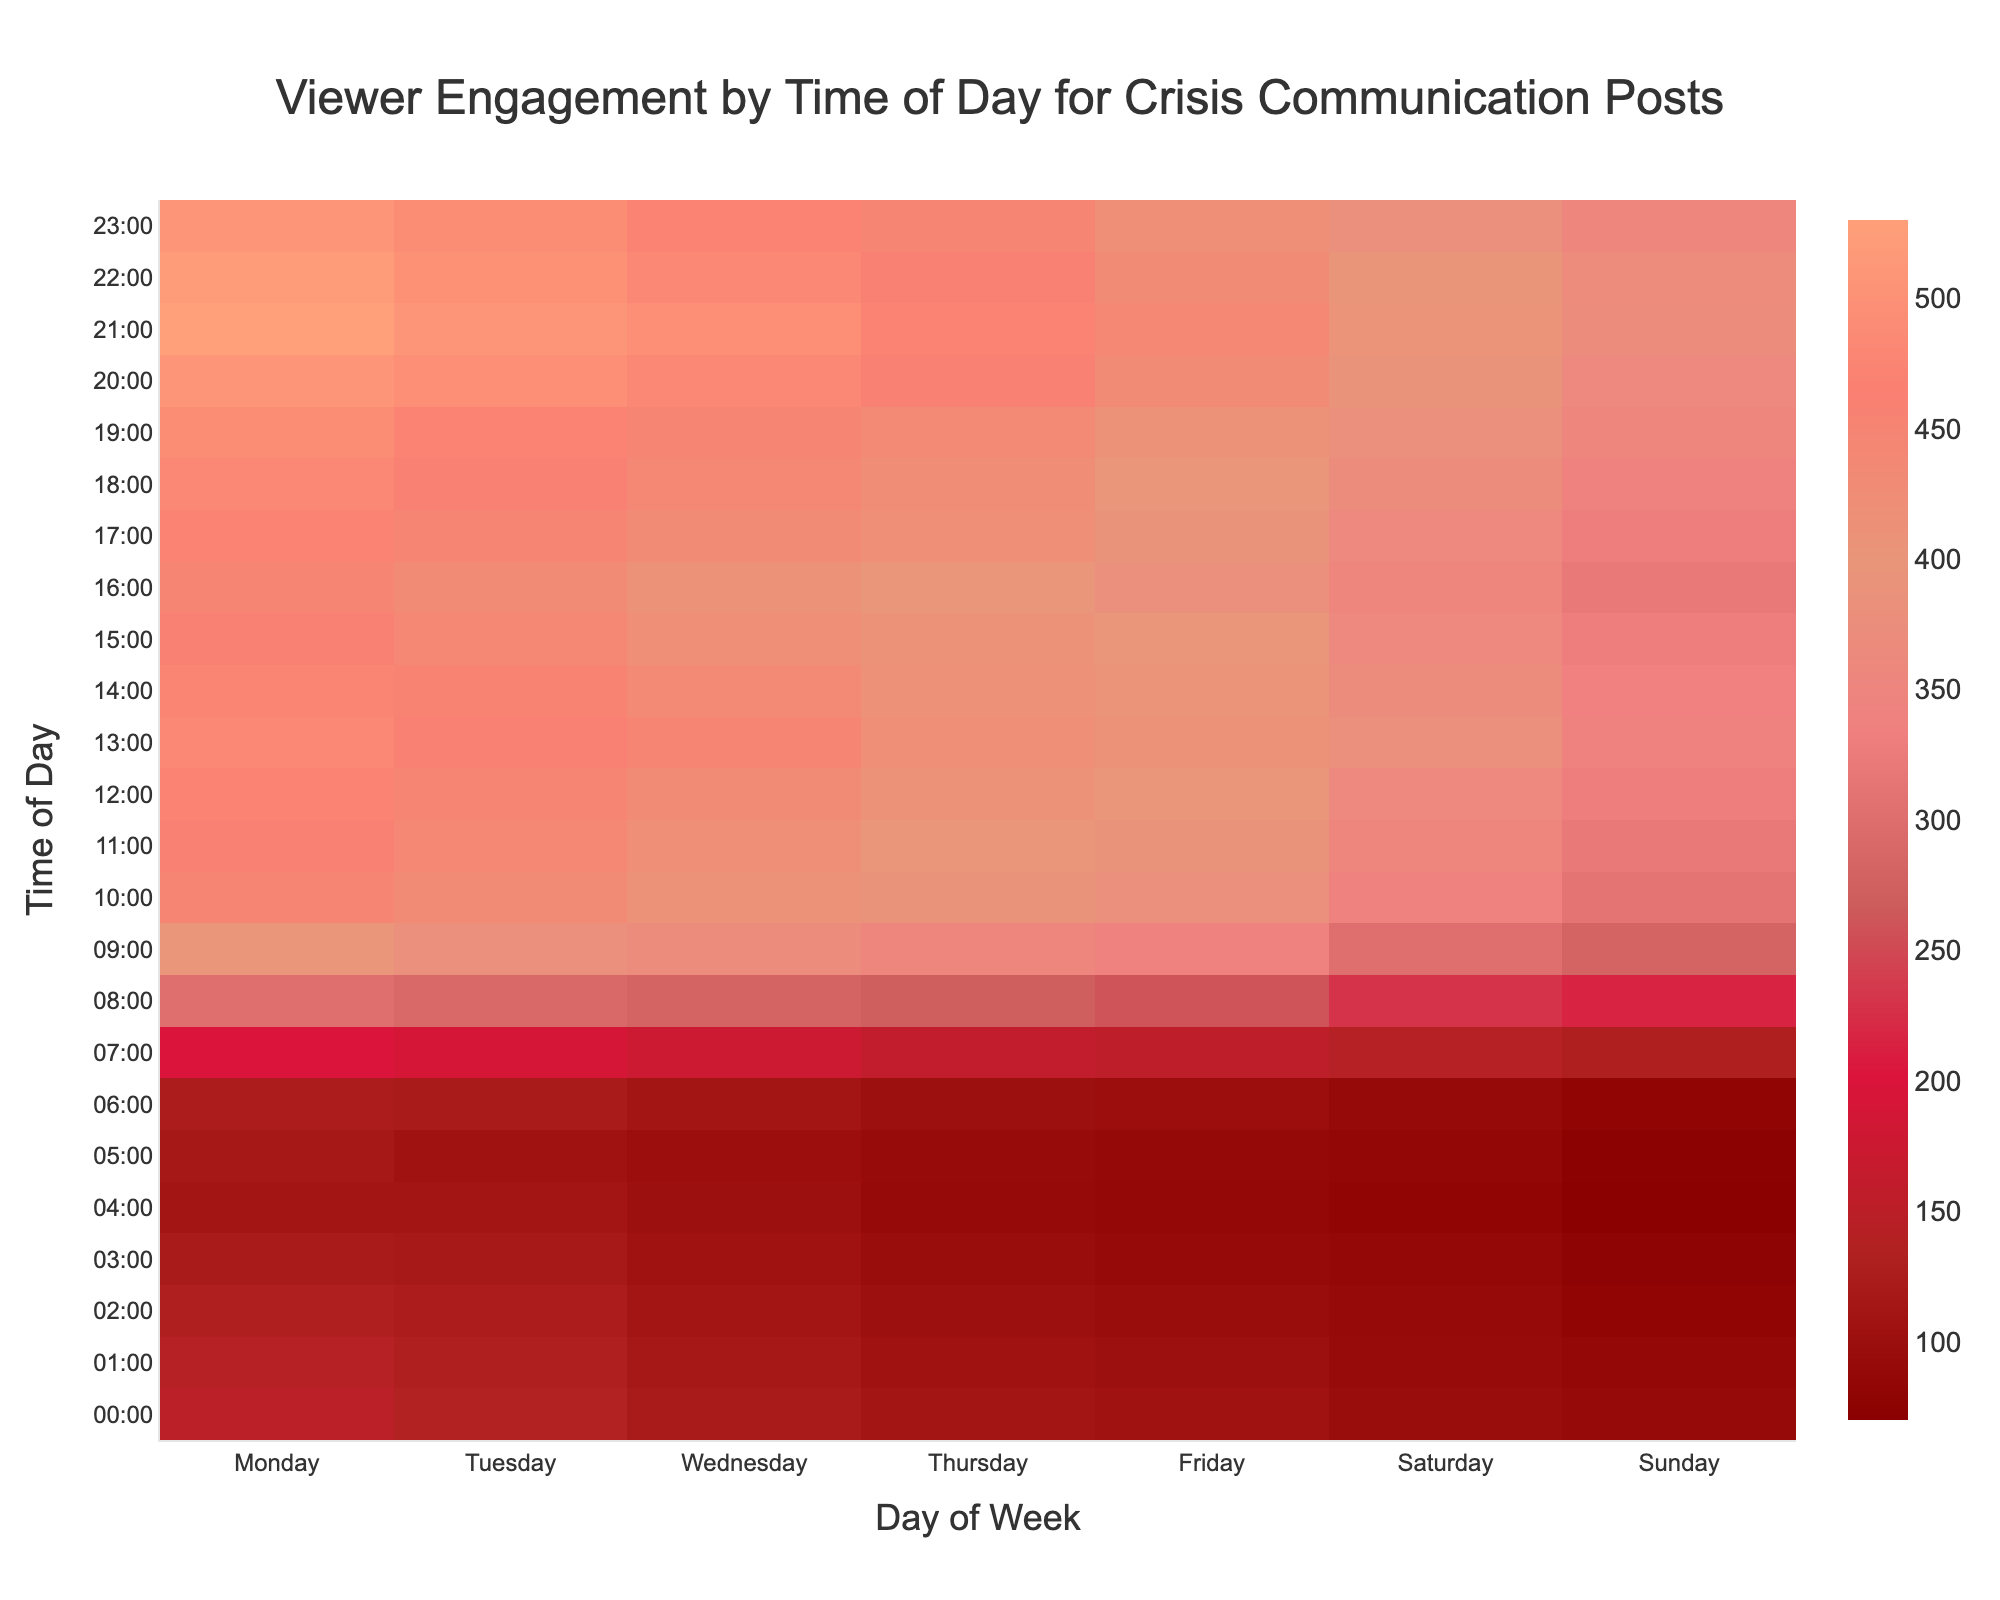What's the title of the heatmap? The title is usually displayed at the top of the figure and conveys the main information about the visualization. Here, the title is "Viewer Engagement by Time of Day for Crisis Communication Posts".
Answer: Viewer Engagement by Time of Day for Crisis Communication Posts Which day has the highest engagement at 8:00 AM? To find this, look at the row corresponding to 8:00 AM. The highest engagement value in that row is 300, which is under Monday.
Answer: Monday At what time do we see a sudden increase in viewer engagement on weekdays? Reviewing the heatmap, there's a noticeable jump between 6:00 AM and 7:00 AM on weekdays. Engagement values rise significantly from 125-155 to 200-155 in this time frame.
Answer: 7:00 AM What's the average engagement on Sunday across all times? The engagement values for Sunday are: 90, 85, 80, 75, 70, 72, 80, 130, 215, 280, 310, 320, 330, 340, 335, 330, 320, 330, 340, 350, 360, 370, 365, and 350. Their sum is 7492, and there are 24 values. The average is 7492 divided by 24.
Answer: 312.17 How does viewer engagement at 9:00 AM on Tuesday compare to Sunday? Check the engagement values at 9:00 AM for both days. Tuesday has 380 and Sunday has 280. Comparing these, Tuesday's engagement is greater than Sunday's by 100.
Answer: 100 more on Tuesday Which two days have the most similar engagements at 10:00 PM and what are the values? Compare the values at 22:00 for all days: Monday (520), Tuesday (500), Wednesday (480), Thursday (460), Friday (430), Saturday (395), and Sunday (365). The closest values are Thursday (460) and Friday (430) with a difference of 30.
Answer: Thursday and Friday: 460, 430 What is the engagement trend throughout the day on Saturday? Looking at the Saturday column, engagement starts lower in the early hours, increases gradually, peaks around midday (noon to afternoon), and then starts to decline towards late night.
Answer: Peaks around midday then declines Which time slot has the highest viewer engagement overall, and what is the value? By reviewing the entire heatmap, the maximum value highlighted is 530, which occurs at 21:00 on Monday.
Answer: 21:00, 530 Compare the engagement at 13:00 on Friday with Wednesday. The values for 13:00 on Friday and Wednesday are 410 and 450, respectively. This indicates that Wednesday has a higher engagement by 40 units.
Answer: Wednesday is higher by 40 units On which day and time is viewer engagement the lowest, and what is the value? By scanning through the heatmap for the smallest value, it is 70, which occurs at 4:00 AM on Sunday.
Answer: Sunday at 4:00 AM, 70 